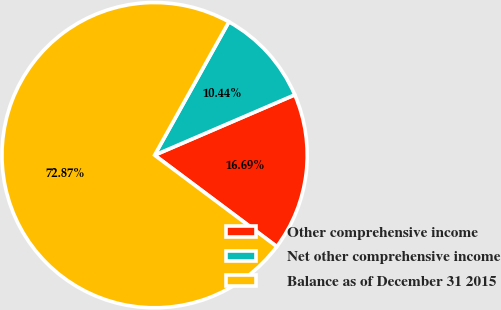Convert chart. <chart><loc_0><loc_0><loc_500><loc_500><pie_chart><fcel>Other comprehensive income<fcel>Net other comprehensive income<fcel>Balance as of December 31 2015<nl><fcel>16.69%<fcel>10.44%<fcel>72.87%<nl></chart> 